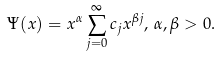Convert formula to latex. <formula><loc_0><loc_0><loc_500><loc_500>\Psi ( x ) = x ^ { \alpha } \sum _ { j = 0 } ^ { \infty } c _ { j } x ^ { \beta j } , \, \alpha , \beta > 0 .</formula> 